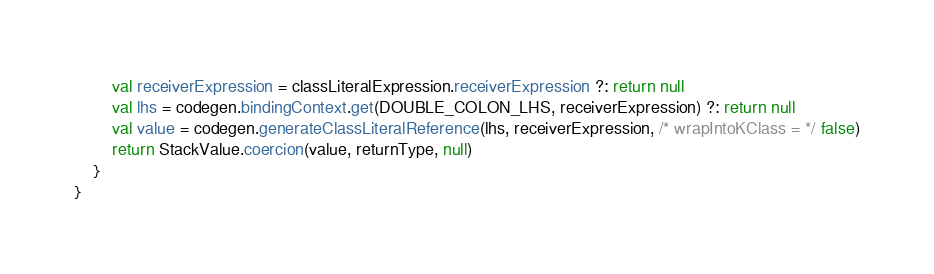<code> <loc_0><loc_0><loc_500><loc_500><_Kotlin_>        val receiverExpression = classLiteralExpression.receiverExpression ?: return null
        val lhs = codegen.bindingContext.get(DOUBLE_COLON_LHS, receiverExpression) ?: return null
        val value = codegen.generateClassLiteralReference(lhs, receiverExpression, /* wrapIntoKClass = */ false)
        return StackValue.coercion(value, returnType, null)
    }
}
</code> 